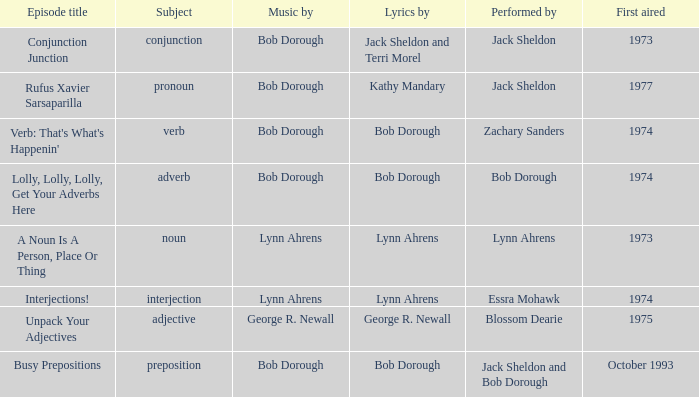When interjection is the subject who are the lyrics by? Lynn Ahrens. 